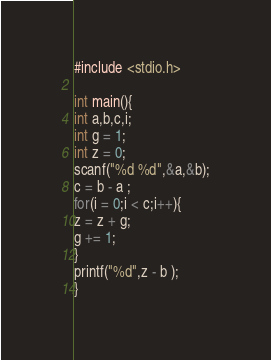<code> <loc_0><loc_0><loc_500><loc_500><_C_>#include <stdio.h>

int main(){
int a,b,c,i;
int g = 1;
int z = 0;
scanf("%d %d",&a,&b);
c = b - a ; 
for(i = 0;i < c;i++){
z = z + g;
g += 1;
}
printf("%d",z - b );
}</code> 